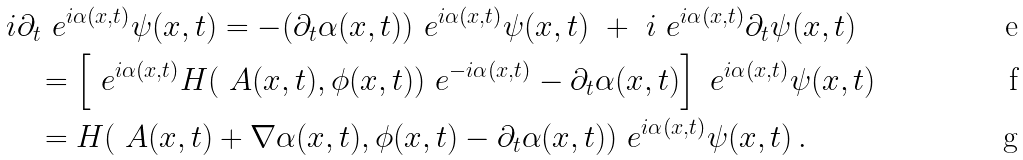<formula> <loc_0><loc_0><loc_500><loc_500>& i \partial _ { t } \ e ^ { i \alpha ( x , t ) } \psi ( x , t ) = - ( \partial _ { t } \alpha ( x , t ) ) \ e ^ { i \alpha ( x , t ) } \psi ( x , t ) \ + \ i \ e ^ { i \alpha ( x , t ) } \partial _ { t } \psi ( x , t ) \\ & \quad = \left [ \ e ^ { i \alpha ( x , t ) } H ( \ A ( x , t ) , \phi ( x , t ) ) \ e ^ { - i \alpha ( x , t ) } - \partial _ { t } \alpha ( x , t ) \right ] \ e ^ { i \alpha ( x , t ) } \psi ( x , t ) \\ & \quad = H ( \ A ( x , t ) + \nabla \alpha ( x , t ) , \phi ( x , t ) - \partial _ { t } \alpha ( x , t ) ) \ e ^ { i \alpha ( x , t ) } \psi ( x , t ) \, .</formula> 